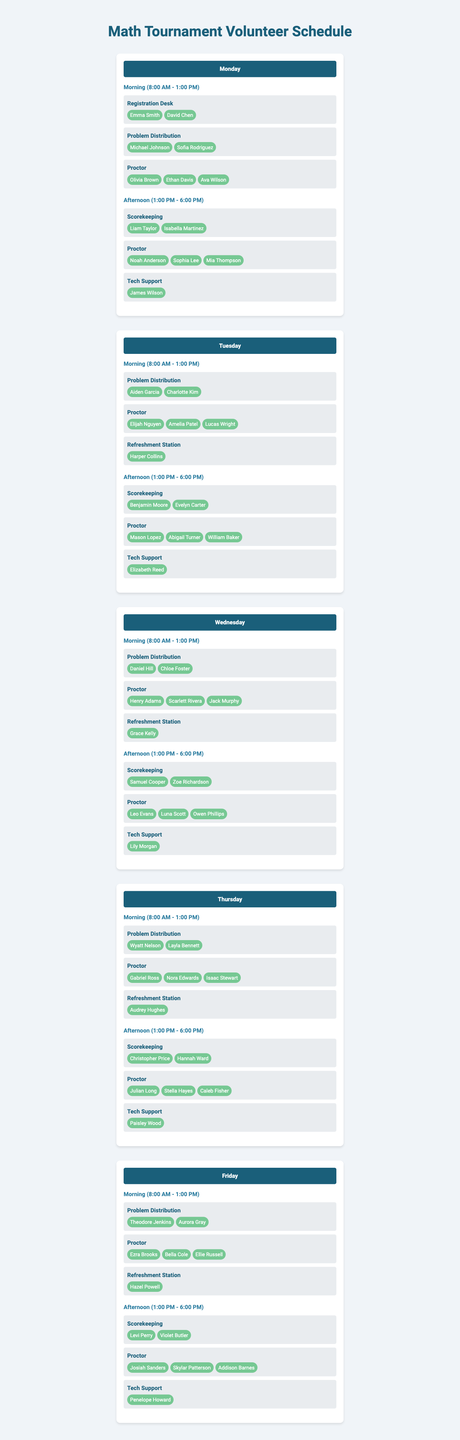What's the total number of volunteers assigned on Monday? On Monday, there are 2 volunteers at the Registration Desk, 2 at Problem Distribution, and 3 proctors in the morning shift, making a total of 2 + 2 + 3 = 7. In the afternoon, there are 2 in Scorekeeping, 3 proctors, and 1 in Tech Support, totaling 2 + 3 + 1 = 6. Summing Monday's totals gives 7 + 6 = 13.
Answer: 13 Who is assigned to the Refreshment Station on Tuesday? On Tuesday, the Refreshment Station is manned by Harper Collins, as indicated in the schedule for the morning shift.
Answer: Harper Collins How many different roles are covered on Friday? On Friday, there are 3 roles in the morning (Problem Distribution, Proctor, Refreshment Station) and 3 roles in the afternoon (Scorekeeping, Proctor, Tech Support). Since the Proctor role is repeated, the distinct roles total 5.
Answer: 5 Is there a volunteer named "Sofia Rodriguez" on any day? Yes, Sofia Rodriguez appears as a volunteer at the Problem Distribution position on Monday.
Answer: Yes Which day has the most volunteers assigned in total? To find this, total the volunteers for each day: Monday: 13, Tuesday: 13, Wednesday: 12, Thursday: 12, Friday: 11. Monday and Tuesday both have the highest total of 13 volunteers each.
Answer: Monday and Tuesday How many total proctors are assigned across the entire tournament? Total the proctors assigned on each day: Monday (3 + 3 = 6), Tuesday (3 + 3 = 6), Wednesday (3 + 3 = 6), Thursday (3 + 3 = 6), and Friday (3 + 3 = 6). Each day has 6 proctors, leading to 6 * 5 = 30 proctors over the tournament.
Answer: 30 Which time slot on Wednesday has the fewest volunteers assigned? The morning shift on Wednesday has 3 roles with a total of 6 volunteers (2 at Problem Distribution, 3 proctors, and 1 at Refreshment Station), while the afternoon shift also has 3 roles but 6 volunteers total (2 in Scorekeeping, 3 proctors, and 1 in Tech Support). Both shifts have the same number of volunteers, so neither has fewer volunteers.
Answer: Both shifts have the same number of volunteers 